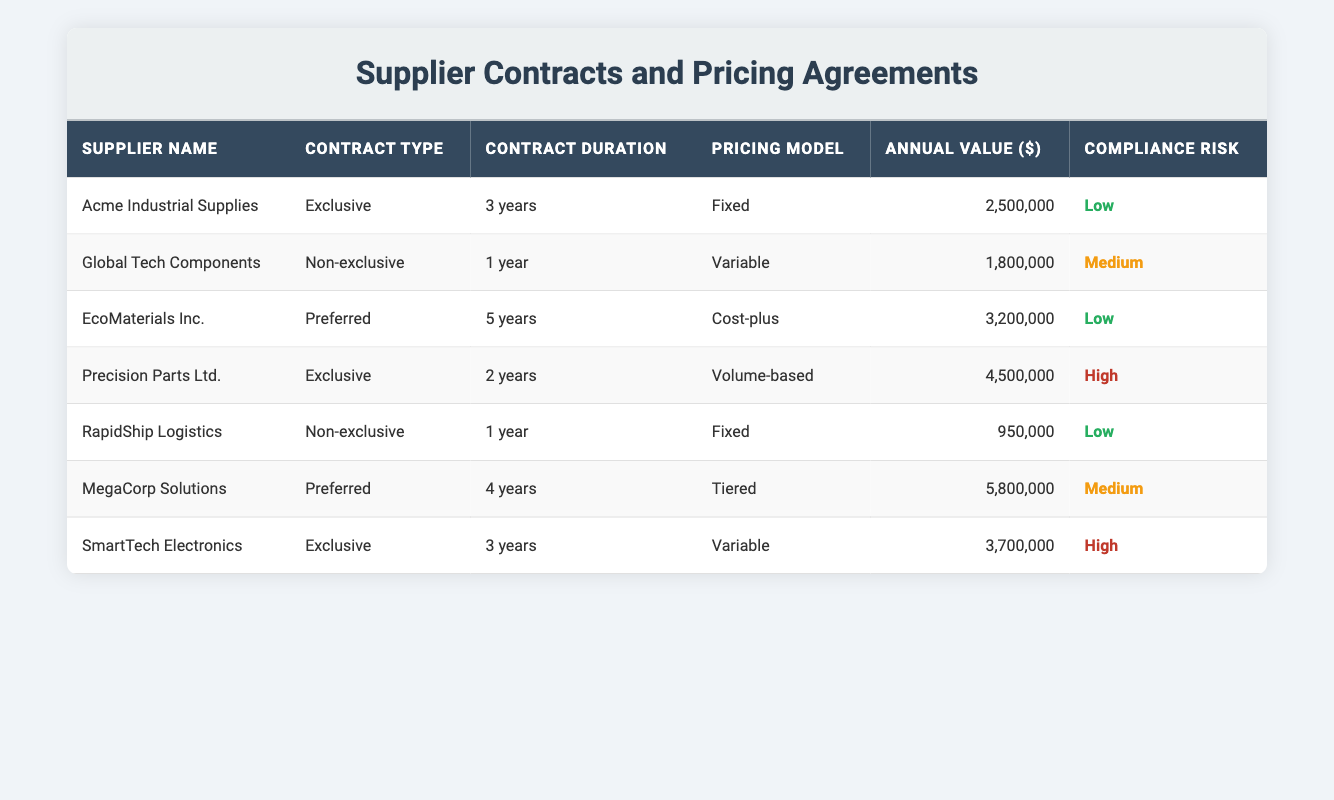What is the annual value of the contract with EcoMaterials Inc.? The table lists the annual value for each supplier. For EcoMaterials Inc., the corresponding annual value is $3,200,000.
Answer: 3,200,000 How many years is the contract duration for Global Tech Components? Looking at the row for Global Tech Components, the contract duration listed is 1 year.
Answer: 1 year Which supplier has the highest compliance risk? The table indicates the compliance risk for each supplier. The supplier with the highest risk is Precision Parts Ltd., categorized under "High".
Answer: Precision Parts Ltd What is the total annual value of the non-exclusive contracts? The non-exclusive contracts are held by Global Tech Components and RapidShip Logistics. Their annual values are $1,800,000 and $950,000, respectively. Summing them gives $1,800,000 + $950,000 = $2,750,000.
Answer: 2,750,000 Is there a supplier with a fixed pricing model that has high compliance risk? Examining the table, the only supplier with a fixed pricing model is Acme Industrial Supplies and RapidShip Logistics. Both of these suppliers have a low compliance risk, so the answer is no.
Answer: No Which contract type has the lowest average annual value? First, we categorize the contracts by type: Exclusive ($2,500,000, $4,500,000, $3,700,000), Non-exclusive ($1,800,000, $950,000), and Preferred ($3,200,000, $5,800,000). Sum and average: Exclusive: (2,500,000 + 4,500,000 + 3,700,000 = 10,700,000) / 3 = 3,566,667; Non-exclusive: (1,800,000 + 950,000) / 2 = 1,375,000; Preferred: (3,200,000 + 5,800,000) / 2 = 4,500,000. The lowest average is for Non-exclusive contracts at $1,375,000.
Answer: Non-exclusive contracts How many suppliers have a contract duration of 3 years or more? Scanning the table, the suppliers with contract durations of 3 years or more are Acme Industrial Supplies (3 years), EcoMaterials Inc. (5 years), MegaCorp Solutions (4 years), and both SmartTech Electronics (3 years). This gives us a total of 4 suppliers.
Answer: 4 suppliers Is there a supplier with a total annual value exceeding 5 million dollars? Looking through the annual values, MegaCorp Solutions has an annual value of $5,800,000, which is greater than 5 million dollars. Therefore, the answer is yes.
Answer: Yes What is the average annual value of contracts with low compliance risk? The suppliers with low compliance risk are Acme Industrial Supplies ($2,500,000), EcoMaterials Inc. ($3,200,000), and RapidShip Logistics ($950,000). Their total is $2,500,000 + $3,200,000 + $950,000 = $6,650,000, and there are 3 suppliers, so the average is $6,650,000 / 3 = $2,216,667.
Answer: 2,216,667 